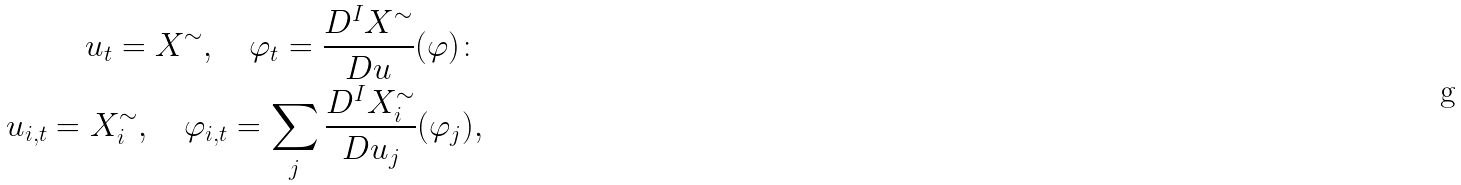<formula> <loc_0><loc_0><loc_500><loc_500>u _ { t } = X ^ { \sim } , \quad \varphi _ { t } = \frac { D ^ { I } X ^ { \sim } } { D u } ( \varphi ) \colon \\ u _ { i , t } = X ^ { \sim } _ { i } , \quad \varphi _ { i , t } = \sum _ { j } \frac { D ^ { I } X ^ { \sim } _ { i } } { D u _ { j } } ( \varphi _ { j } ) ,</formula> 